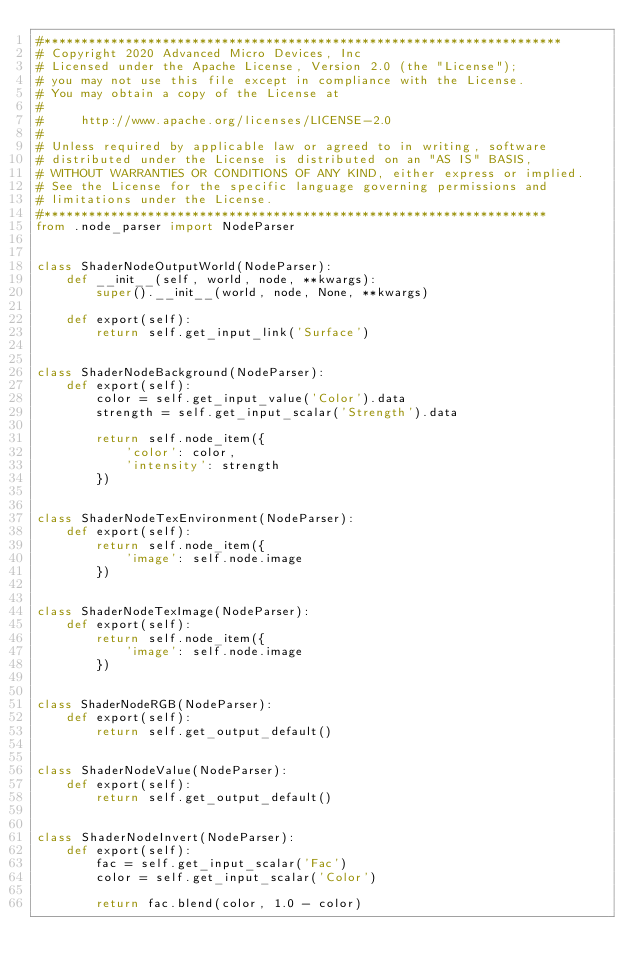Convert code to text. <code><loc_0><loc_0><loc_500><loc_500><_Python_>#**********************************************************************
# Copyright 2020 Advanced Micro Devices, Inc
# Licensed under the Apache License, Version 2.0 (the "License");
# you may not use this file except in compliance with the License.
# You may obtain a copy of the License at
#
#     http://www.apache.org/licenses/LICENSE-2.0
#
# Unless required by applicable law or agreed to in writing, software
# distributed under the License is distributed on an "AS IS" BASIS,
# WITHOUT WARRANTIES OR CONDITIONS OF ANY KIND, either express or implied.
# See the License for the specific language governing permissions and
# limitations under the License.
#********************************************************************
from .node_parser import NodeParser


class ShaderNodeOutputWorld(NodeParser):
    def __init__(self, world, node, **kwargs):
        super().__init__(world, node, None, **kwargs)

    def export(self):
        return self.get_input_link('Surface')


class ShaderNodeBackground(NodeParser):
    def export(self):
        color = self.get_input_value('Color').data
        strength = self.get_input_scalar('Strength').data

        return self.node_item({
            'color': color,
            'intensity': strength
        })


class ShaderNodeTexEnvironment(NodeParser):
    def export(self):
        return self.node_item({
            'image': self.node.image
        })


class ShaderNodeTexImage(NodeParser):
    def export(self):
        return self.node_item({
            'image': self.node.image
        })


class ShaderNodeRGB(NodeParser):
    def export(self):
        return self.get_output_default()


class ShaderNodeValue(NodeParser):
    def export(self):
        return self.get_output_default()


class ShaderNodeInvert(NodeParser):
    def export(self):
        fac = self.get_input_scalar('Fac')
        color = self.get_input_scalar('Color')

        return fac.blend(color, 1.0 - color)
</code> 